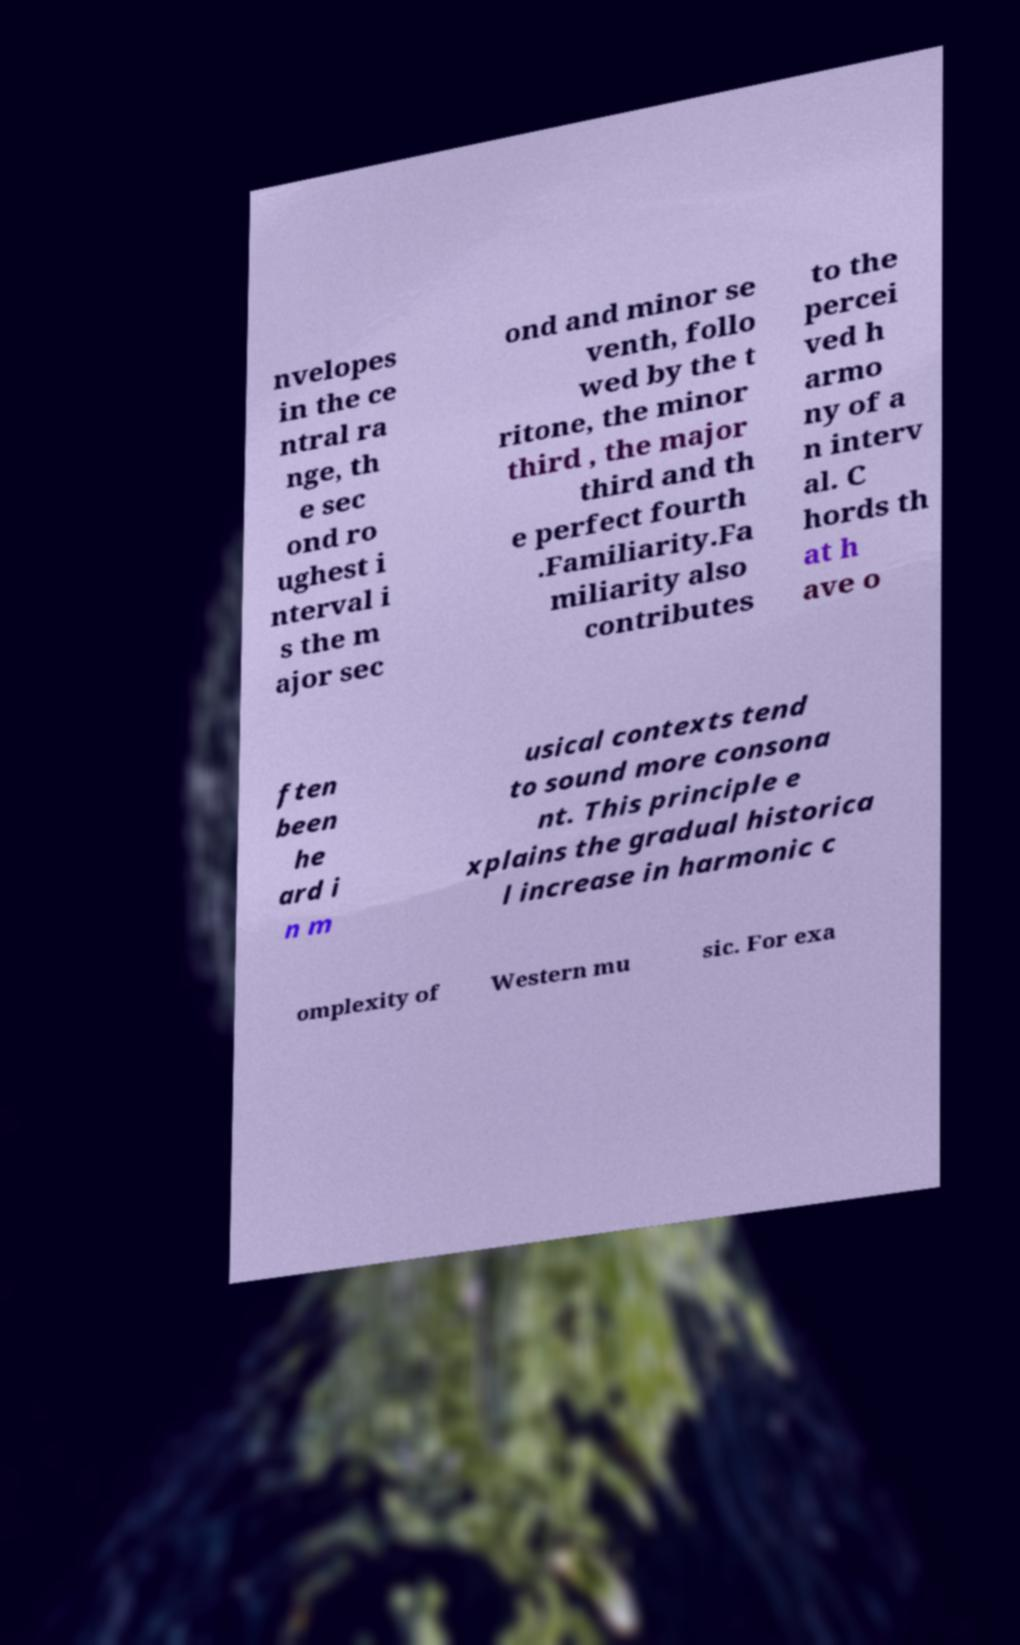Can you accurately transcribe the text from the provided image for me? nvelopes in the ce ntral ra nge, th e sec ond ro ughest i nterval i s the m ajor sec ond and minor se venth, follo wed by the t ritone, the minor third , the major third and th e perfect fourth .Familiarity.Fa miliarity also contributes to the percei ved h armo ny of a n interv al. C hords th at h ave o ften been he ard i n m usical contexts tend to sound more consona nt. This principle e xplains the gradual historica l increase in harmonic c omplexity of Western mu sic. For exa 